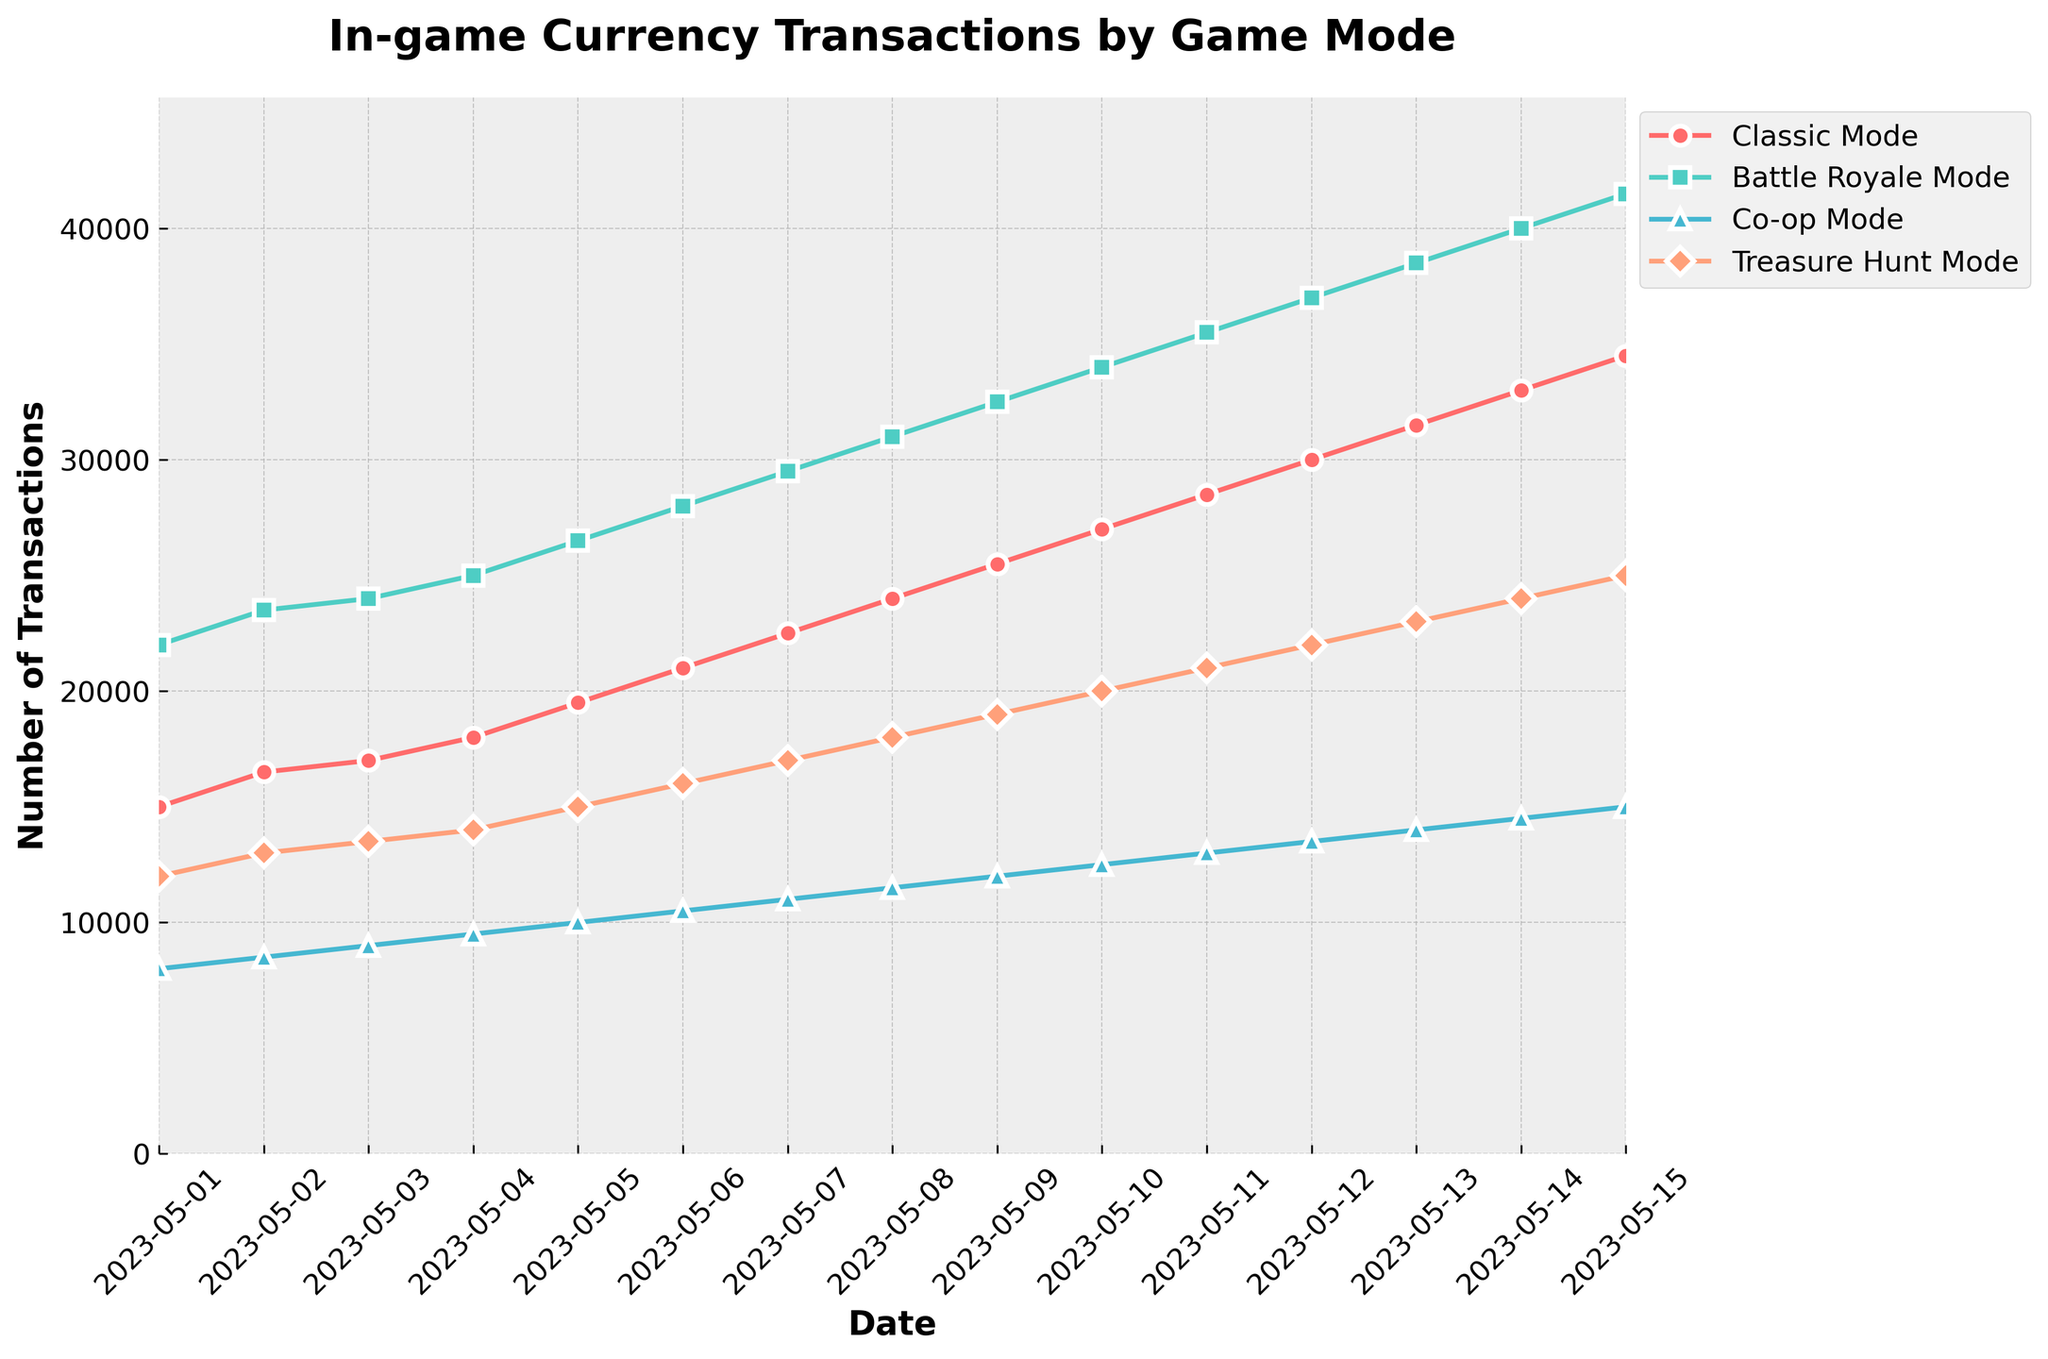Which game mode had the highest number of transactions on May 10, 2023? On May 10, 2023, look at the data for each game mode. 'Battle Royale Mode' has the highest number of transactions with 34,000.
Answer: Battle Royale Mode What is the difference between the transactions in Classic Mode and Co-op Mode on May 05, 2023? On May 05, 2023, transactions in 'Classic Mode' are 19,500 and Co-op Mode are 10,000. The difference is 19,500 - 10,000 = 9,500.
Answer: 9,500 Between which two consecutive dates did the total daily transactions increase the most? Look at the 'Total Daily Transactions' column and identify the largest increase between any two consecutive dates. The largest increase is between May 14 and May 15, from 111,500 to 116,000, an increase of 4,500.
Answer: May 14 and May 15 Which game mode showed a consistent increase in transactions every day? Check each game mode's trends and see which one consistently increases. 'Battle Royale Mode' shows an increase every day.
Answer: Battle Royale Mode How much did the transactions in the Treasure Hunt Mode increase from May 01, 2023, to May 15, 2023? On May 01, 2023, transactions in 'Treasure Hunt Mode' are 12,000 and on May 15, 2023, they are 25,000. The increase is 25,000 - 12,000 = 13,000.
Answer: 13,000 On May 03, 2023, which game mode had the smallest number of transactions, and how many were those? On May 03, 2023, 'Co-op Mode' had the smallest number of transactions with 9,000.
Answer: Co-op Mode, 9,000 What is the total number of transactions for all game modes combined on May 07, 2023? Sum up the transactions for all game modes on May 07, 2023. 22,500 (Classic Mode) + 29,500 (Battle Royale Mode) + 11,000 (Co-op Mode) + 17,000 (Treasure Hunt Mode) = 80,000.
Answer: 80,000 By how much did transactions in Classic Mode increase from May 01, 2023, to May 15, 2023? On May 01, 2023, transactions in 'Classic Mode' are 15,000 and on May 15, 2023, they are 34,500. The increase is 34,500 - 15,000 = 19,500.
Answer: 19,500 Which game mode had the second highest number of transactions on May 14, 2023? On May 14, 2023, the transactions are: Classic Mode (33,000), Battle Royale Mode (40,000), Co-op Mode (14,500), Treasure Hunt Mode (24,000). The second highest is 'Classic Mode' with 33,000 transactions.
Answer: Classic Mode 